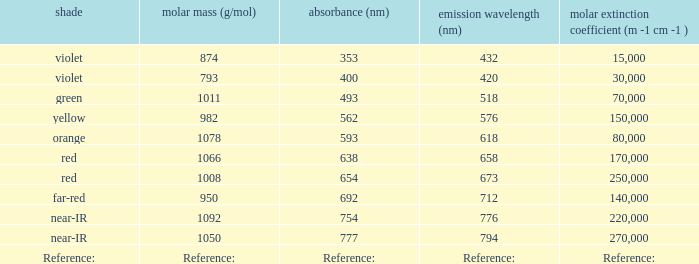Which Emission (in nanometers) has an absorbtion of 593 nm? 618.0. 